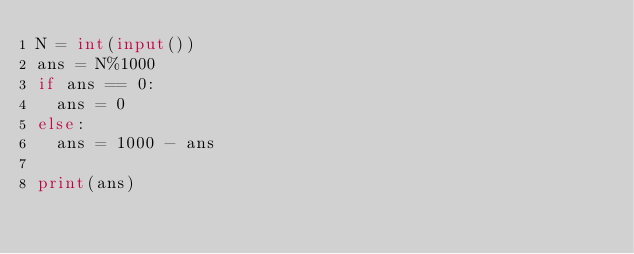Convert code to text. <code><loc_0><loc_0><loc_500><loc_500><_Python_>N = int(input())
ans = N%1000
if ans == 0:
  ans = 0
else:
  ans = 1000 - ans

print(ans)</code> 